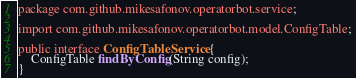<code> <loc_0><loc_0><loc_500><loc_500><_Java_>package com.github.mikesafonov.operatorbot.service;

import com.github.mikesafonov.operatorbot.model.ConfigTable;

public interface ConfigTableService {
    ConfigTable findByConfig(String config);
}
</code> 